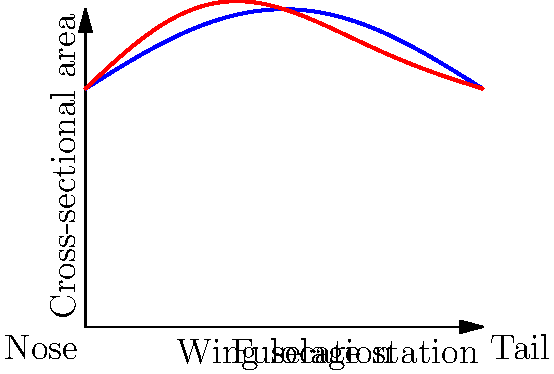Based on the graph showing the ideal and actual cross-sectional area distribution of an aircraft fuselage, which region should be modified to better conform to area ruling principles and minimize wave drag? To answer this question, we need to analyze the graph and understand the principles of area ruling:

1. The blue curve represents the ideal area distribution according to area ruling principles.
2. The red curve shows the actual area distribution of the current design.
3. Area ruling aims to minimize wave drag by smoothing out the changes in cross-sectional area along the fuselage.

To identify the region that needs modification:

1. Compare the two curves and look for significant deviations.
2. The most notable difference occurs around the middle of the fuselage (x ≈ 5), which likely corresponds to the wing location.
3. In this region, the actual distribution (red curve) shows a more pronounced "bump" compared to the ideal distribution (blue curve).
4. This extra volume in the middle section violates the area ruling principle of maintaining a smooth area distribution.

Therefore, the region around the wing location (middle of the fuselage) should be modified to reduce the cross-sectional area and better conform to the ideal distribution curve. This modification will help minimize wave drag according to area ruling principles.
Answer: Wing location region 